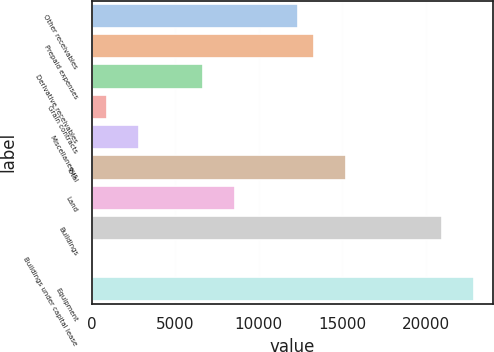Convert chart to OTSL. <chart><loc_0><loc_0><loc_500><loc_500><bar_chart><fcel>Other receivables<fcel>Prepaid expenses<fcel>Derivative receivables<fcel>Grain contracts<fcel>Miscellaneous<fcel>Total<fcel>Land<fcel>Buildings<fcel>Buildings under capital lease<fcel>Equipment<nl><fcel>12384.5<fcel>13337.1<fcel>6668.71<fcel>952.93<fcel>2858.19<fcel>15242.4<fcel>8573.97<fcel>20958.2<fcel>0.3<fcel>22863.4<nl></chart> 